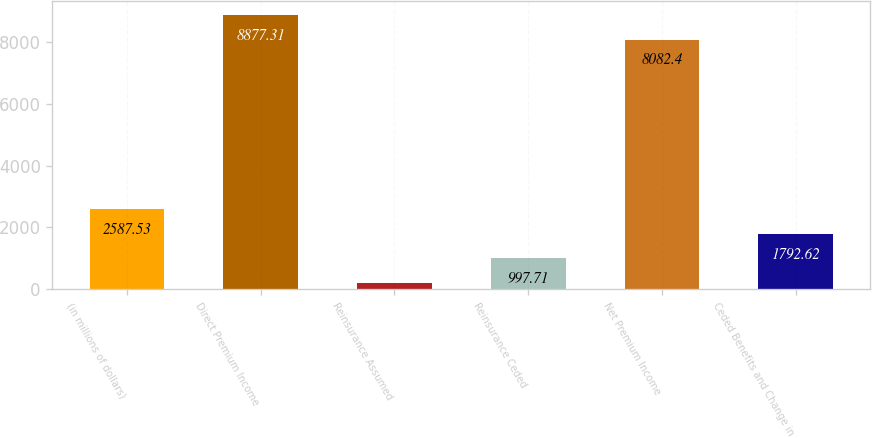Convert chart to OTSL. <chart><loc_0><loc_0><loc_500><loc_500><bar_chart><fcel>(in millions of dollars)<fcel>Direct Premium Income<fcel>Reinsurance Assumed<fcel>Reinsurance Ceded<fcel>Net Premium Income<fcel>Ceded Benefits and Change in<nl><fcel>2587.53<fcel>8877.31<fcel>202.8<fcel>997.71<fcel>8082.4<fcel>1792.62<nl></chart> 